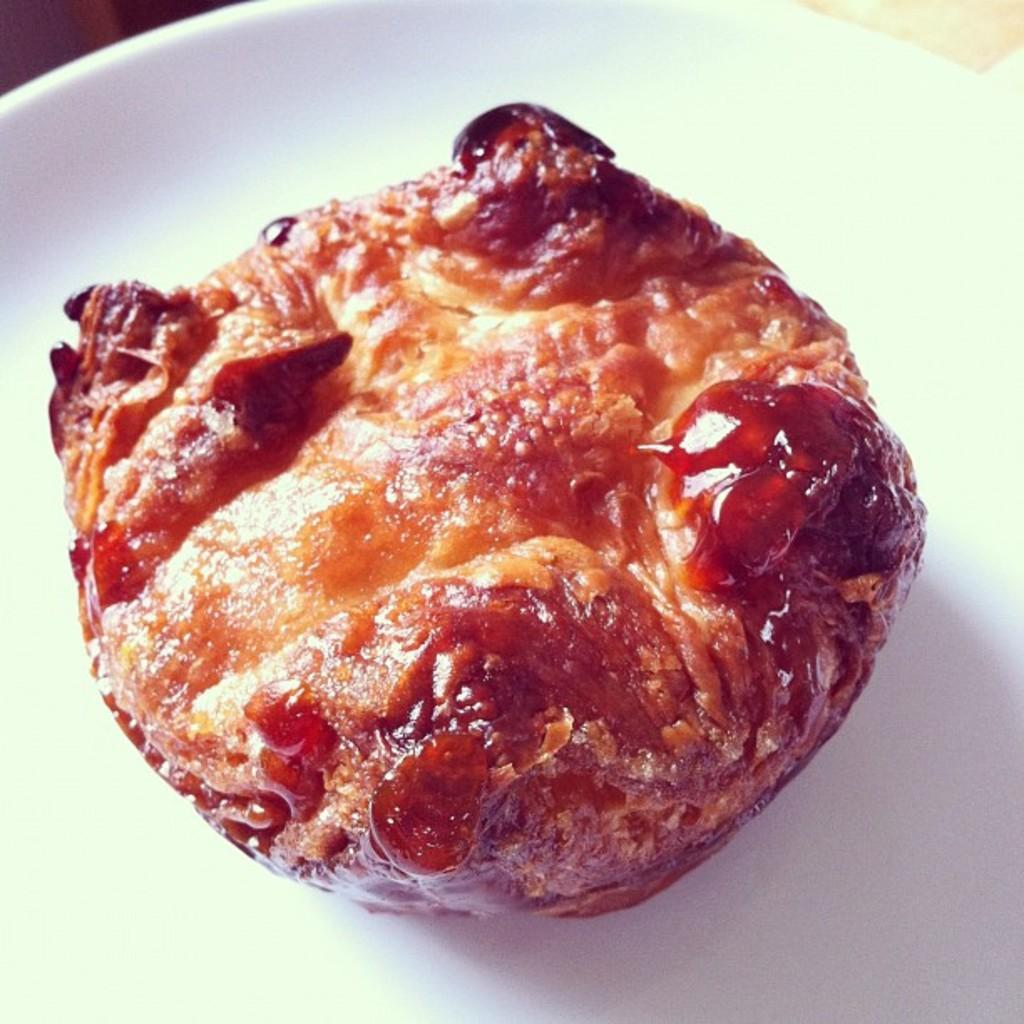What is present on the plate in the image? There is food on the plate in the image. Can you describe the plate itself? The facts provided do not give any details about the plate, only that it is present in the image. How many legs are visible in the image? There is no information about legs in the image, as it only mentions a plate with food on it. 